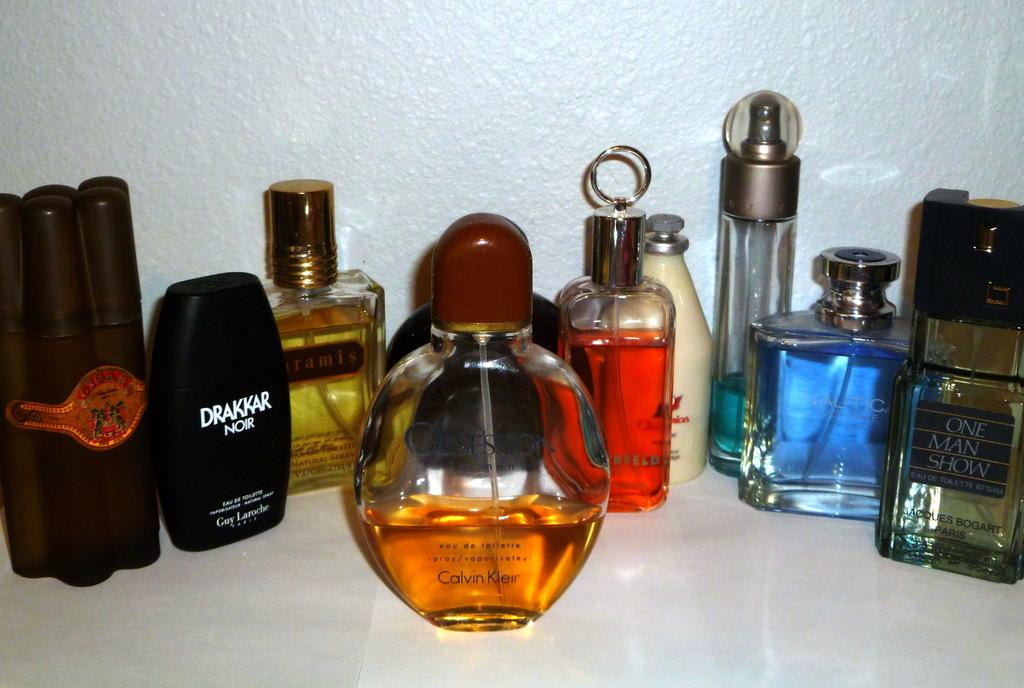<image>
Share a concise interpretation of the image provided. A black bottle has the words Drakkar Noir in white. 